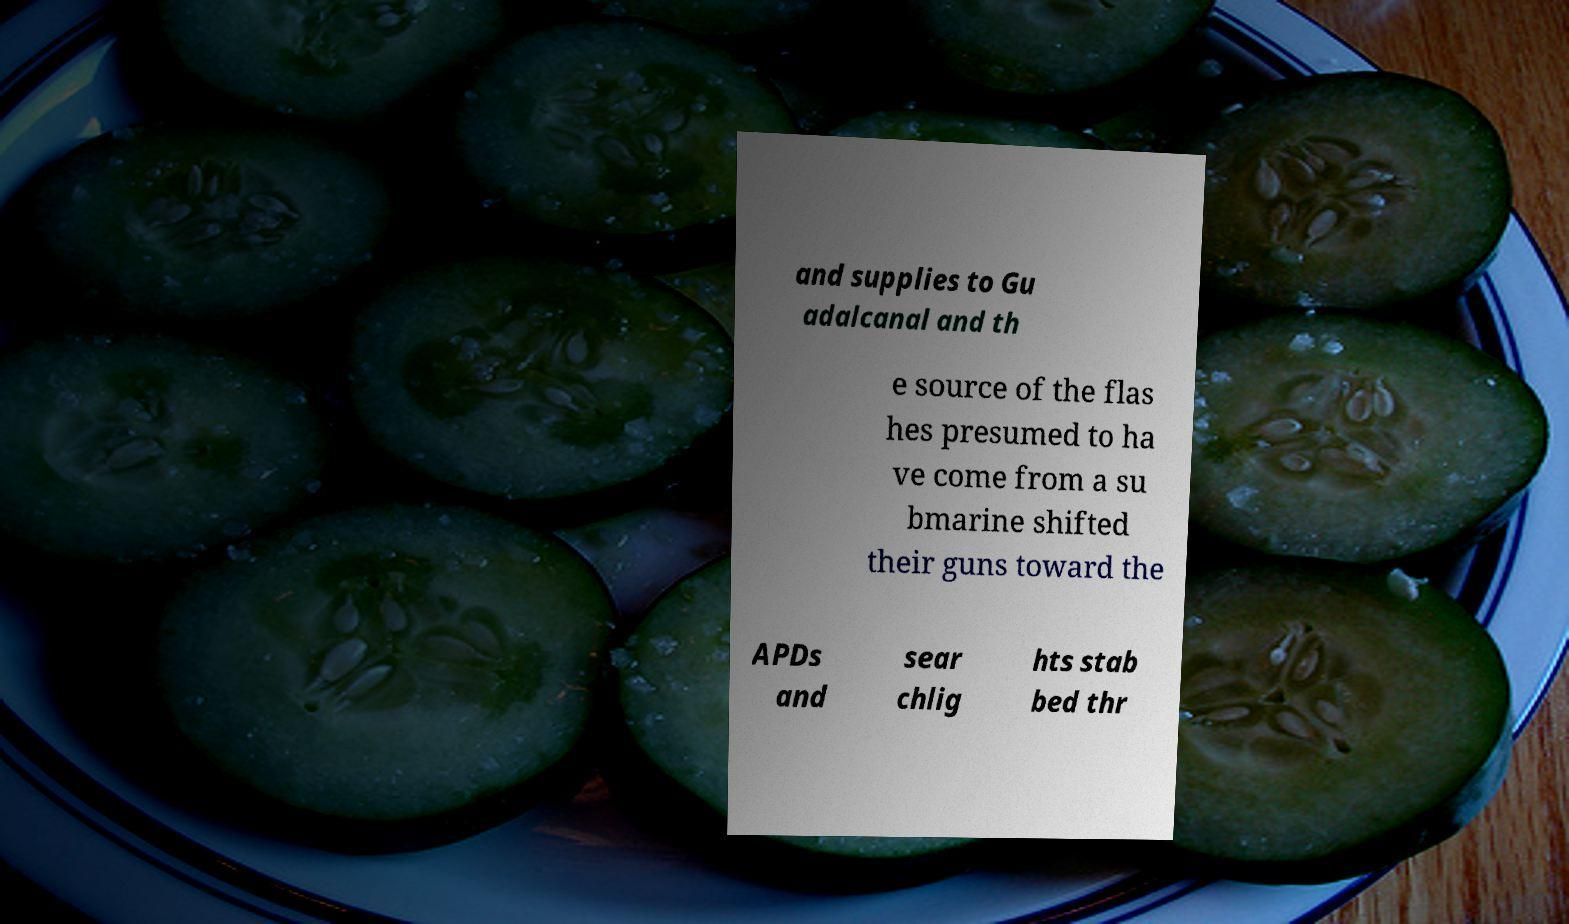Can you read and provide the text displayed in the image?This photo seems to have some interesting text. Can you extract and type it out for me? and supplies to Gu adalcanal and th e source of the flas hes presumed to ha ve come from a su bmarine shifted their guns toward the APDs and sear chlig hts stab bed thr 